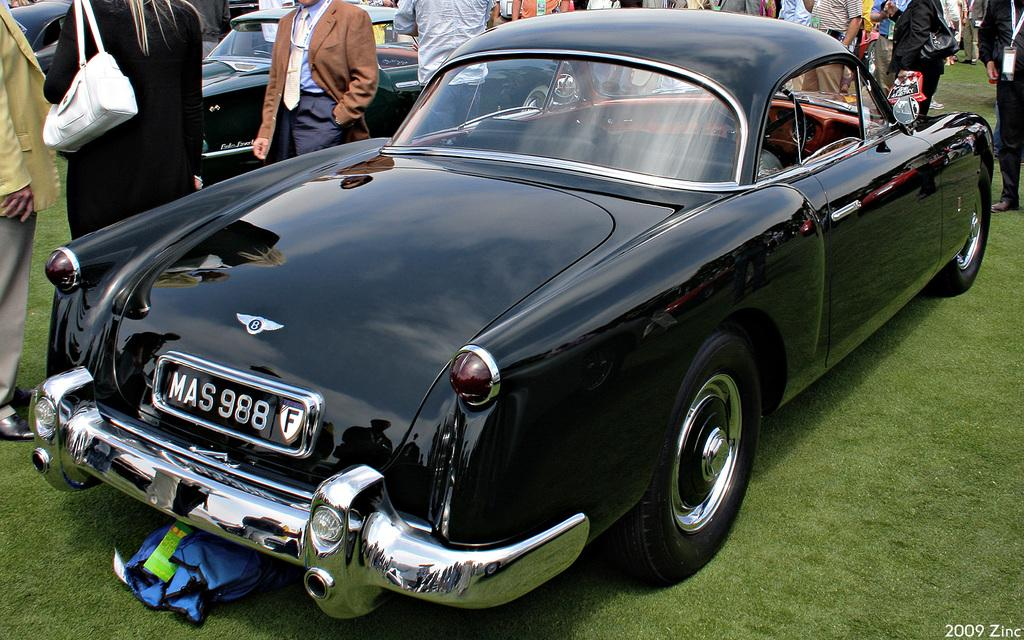What type of vehicles can be seen in the image? There are cars in the image. How are the cars positioned in the image? The cars are placed on the ground. What type of vegetation is visible in the image? There is grass visible in the image. What object can be seen on the ground in the image? There is a bag on the ground in the image. Can you describe the people in the image? There is a group of people standing in the image. What type of show is the minister currently attending in the image? There is no show or minister present in the image; it features cars, grass, a bag, and a group of people. 